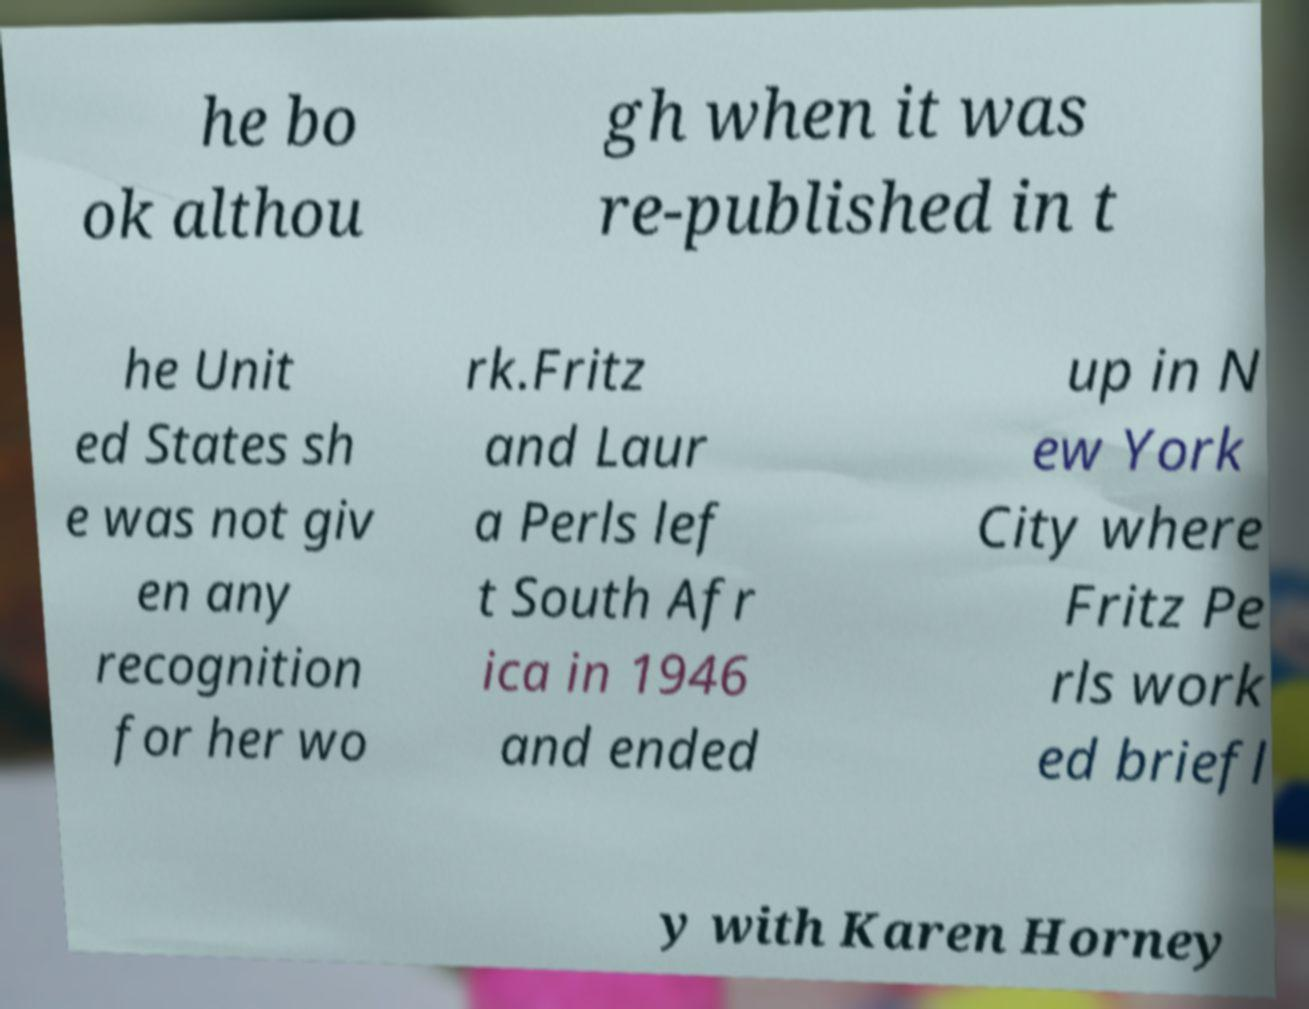Could you extract and type out the text from this image? he bo ok althou gh when it was re-published in t he Unit ed States sh e was not giv en any recognition for her wo rk.Fritz and Laur a Perls lef t South Afr ica in 1946 and ended up in N ew York City where Fritz Pe rls work ed briefl y with Karen Horney 